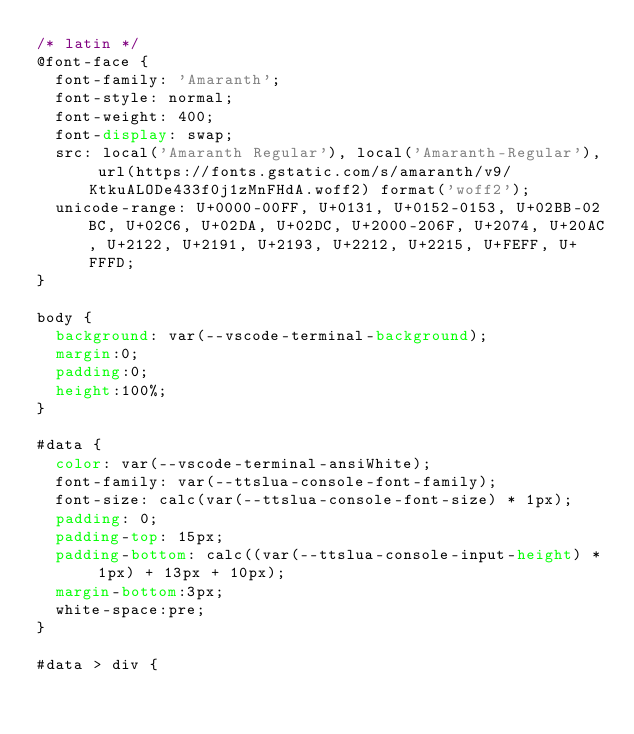Convert code to text. <code><loc_0><loc_0><loc_500><loc_500><_CSS_>/* latin */
@font-face {
  font-family: 'Amaranth';
  font-style: normal;
  font-weight: 400;
  font-display: swap;
  src: local('Amaranth Regular'), local('Amaranth-Regular'), url(https://fonts.gstatic.com/s/amaranth/v9/KtkuALODe433f0j1zMnFHdA.woff2) format('woff2');
  unicode-range: U+0000-00FF, U+0131, U+0152-0153, U+02BB-02BC, U+02C6, U+02DA, U+02DC, U+2000-206F, U+2074, U+20AC, U+2122, U+2191, U+2193, U+2212, U+2215, U+FEFF, U+FFFD;
}

body {
  background: var(--vscode-terminal-background);
  margin:0;
  padding:0;
  height:100%;
}

#data {
  color: var(--vscode-terminal-ansiWhite);
  font-family: var(--ttslua-console-font-family);
  font-size: calc(var(--ttslua-console-font-size) * 1px);
  padding: 0;
  padding-top: 15px;
  padding-bottom: calc((var(--ttslua-console-input-height) * 1px) + 13px + 10px);
  margin-bottom:3px;
  white-space:pre;
}

#data > div {</code> 